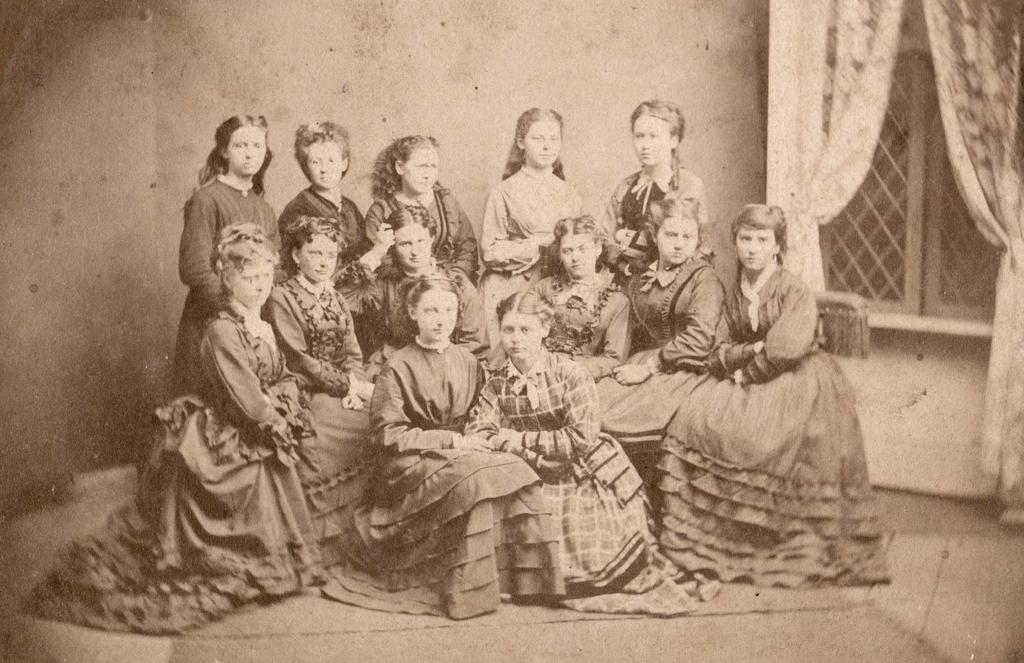How many girls are present in the image? There are multiple girls in the image. What are the positions of the girls in the image? Some of the girls are sitting, and some are standing. What type of stocking is the girl wearing in the image? There is no mention of stockings or any specific clothing items in the image, so it cannot be determined. 